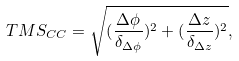<formula> <loc_0><loc_0><loc_500><loc_500>T M S _ { C C } = \sqrt { ( \frac { \Delta \phi } { \delta _ { \Delta \phi } } ) ^ { 2 } + ( \frac { \Delta z } { \delta _ { \Delta z } } ) ^ { 2 } } ,</formula> 